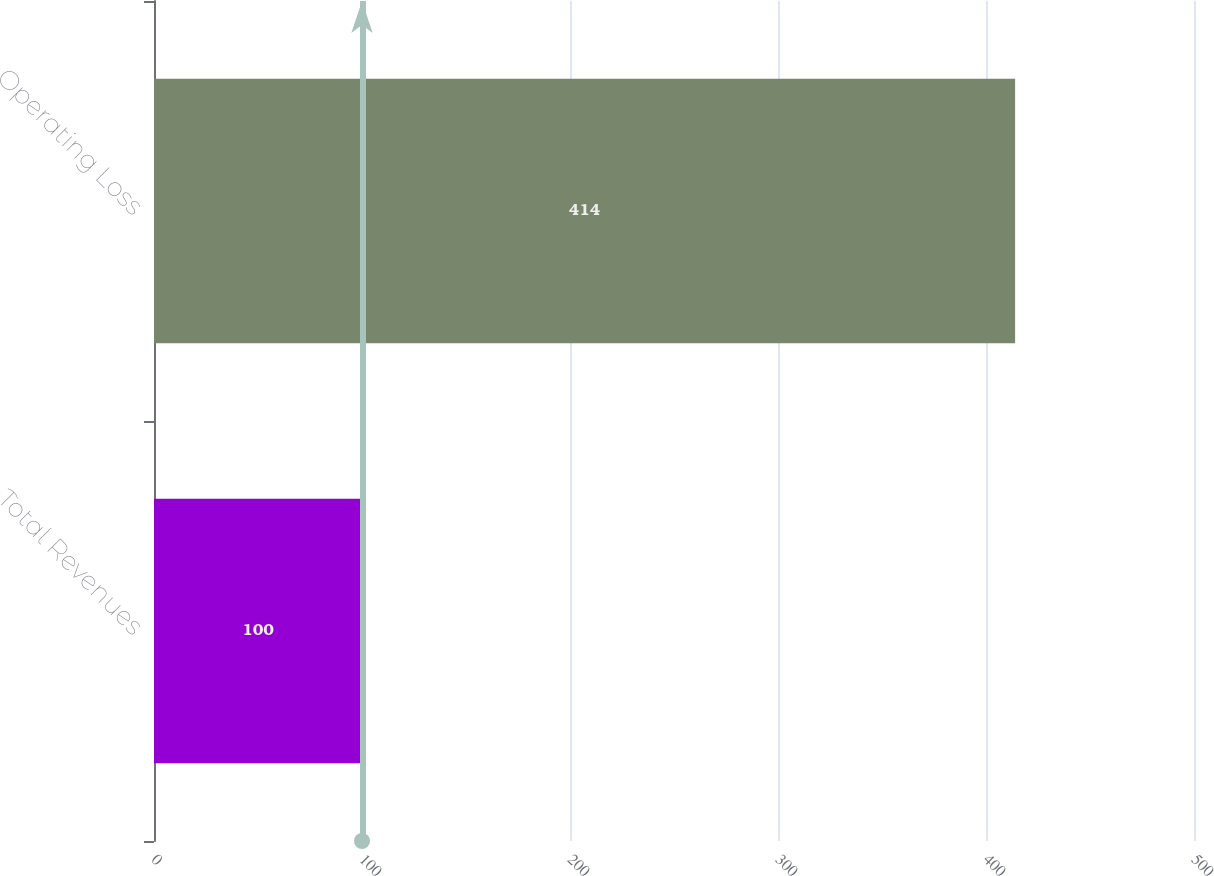<chart> <loc_0><loc_0><loc_500><loc_500><bar_chart><fcel>Total Revenues<fcel>Operating Loss<nl><fcel>100<fcel>414<nl></chart> 